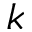Convert formula to latex. <formula><loc_0><loc_0><loc_500><loc_500>k</formula> 